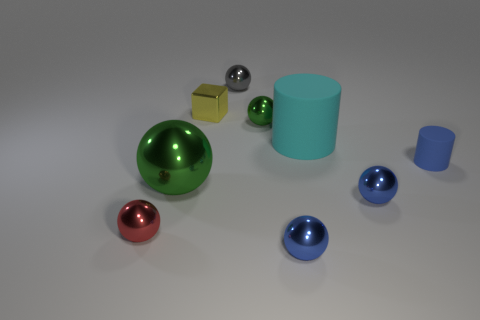Subtract all green balls. How many balls are left? 4 Subtract all gray balls. How many balls are left? 5 Subtract all green balls. Subtract all yellow cylinders. How many balls are left? 4 Subtract all balls. How many objects are left? 3 Subtract 0 yellow cylinders. How many objects are left? 9 Subtract all tiny blue cylinders. Subtract all yellow metal objects. How many objects are left? 7 Add 4 red objects. How many red objects are left? 5 Add 5 large cyan things. How many large cyan things exist? 6 